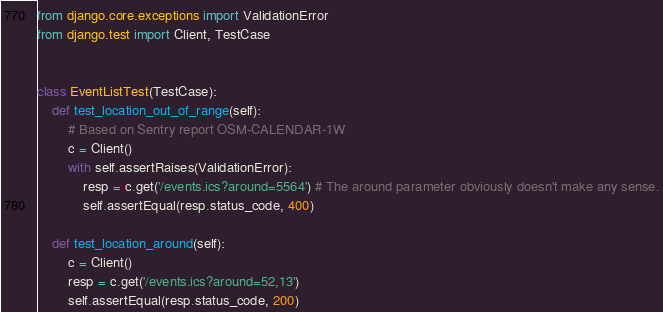Convert code to text. <code><loc_0><loc_0><loc_500><loc_500><_Python_>from django.core.exceptions import ValidationError
from django.test import Client, TestCase


class EventListTest(TestCase):
    def test_location_out_of_range(self):
        # Based on Sentry report OSM-CALENDAR-1W
        c = Client()
        with self.assertRaises(ValidationError):
            resp = c.get('/events.ics?around=5564') # The around parameter obviously doesn't make any sense.
            self.assertEqual(resp.status_code, 400)

    def test_location_around(self):
        c = Client()
        resp = c.get('/events.ics?around=52,13')
        self.assertEqual(resp.status_code, 200)
</code> 